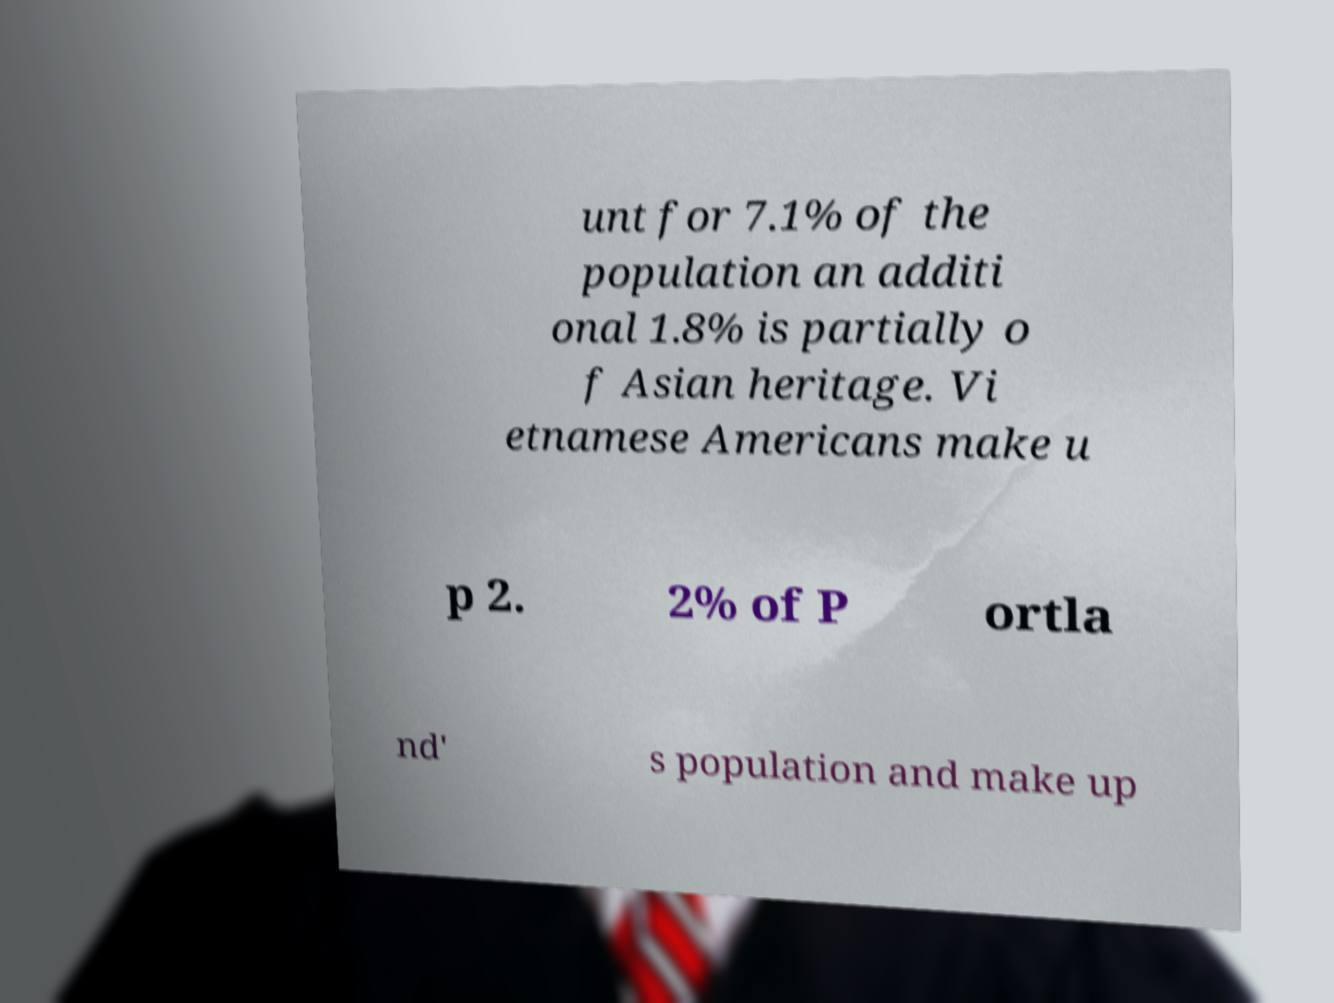Please read and relay the text visible in this image. What does it say? unt for 7.1% of the population an additi onal 1.8% is partially o f Asian heritage. Vi etnamese Americans make u p 2. 2% of P ortla nd' s population and make up 